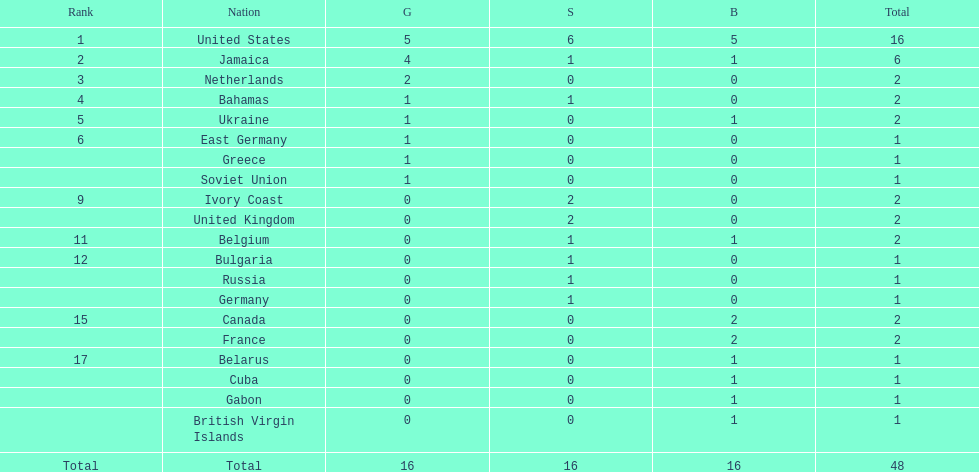After the united states, what country won the most gold medals. Jamaica. 